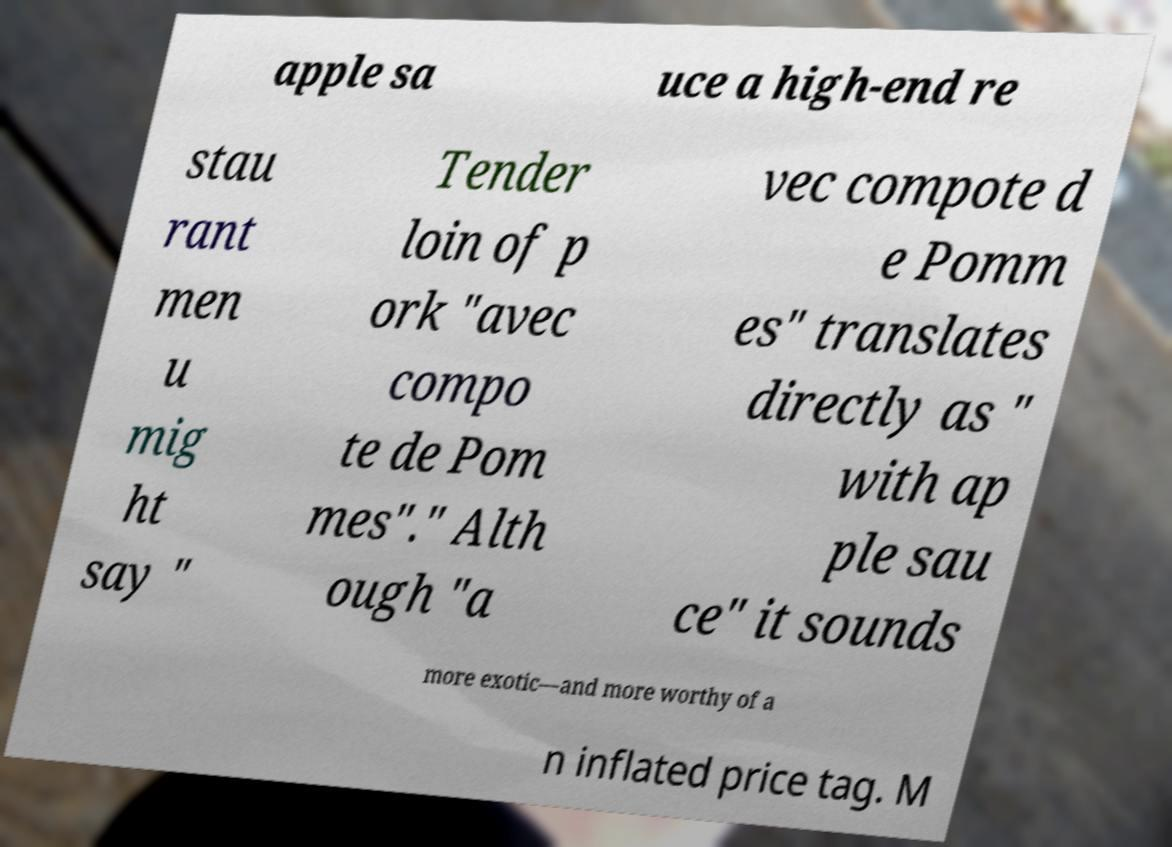Can you read and provide the text displayed in the image?This photo seems to have some interesting text. Can you extract and type it out for me? apple sa uce a high-end re stau rant men u mig ht say " Tender loin of p ork "avec compo te de Pom mes"." Alth ough "a vec compote d e Pomm es" translates directly as " with ap ple sau ce" it sounds more exotic—and more worthy of a n inflated price tag. M 